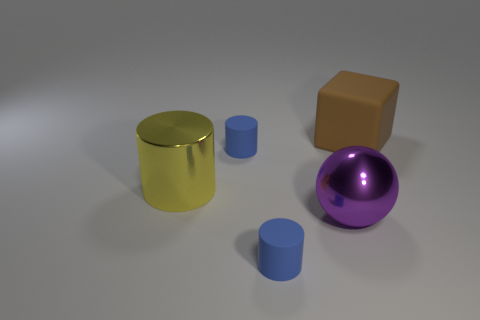Subtract all tiny cylinders. How many cylinders are left? 1 Subtract all blue cylinders. How many cylinders are left? 1 Subtract all balls. How many objects are left? 4 Add 3 yellow cylinders. How many objects exist? 8 Subtract 1 blocks. How many blocks are left? 0 Subtract all yellow blocks. Subtract all yellow cylinders. How many blocks are left? 1 Subtract all yellow blocks. How many blue cylinders are left? 2 Subtract all large brown rubber objects. Subtract all big objects. How many objects are left? 1 Add 2 rubber cylinders. How many rubber cylinders are left? 4 Add 4 brown objects. How many brown objects exist? 5 